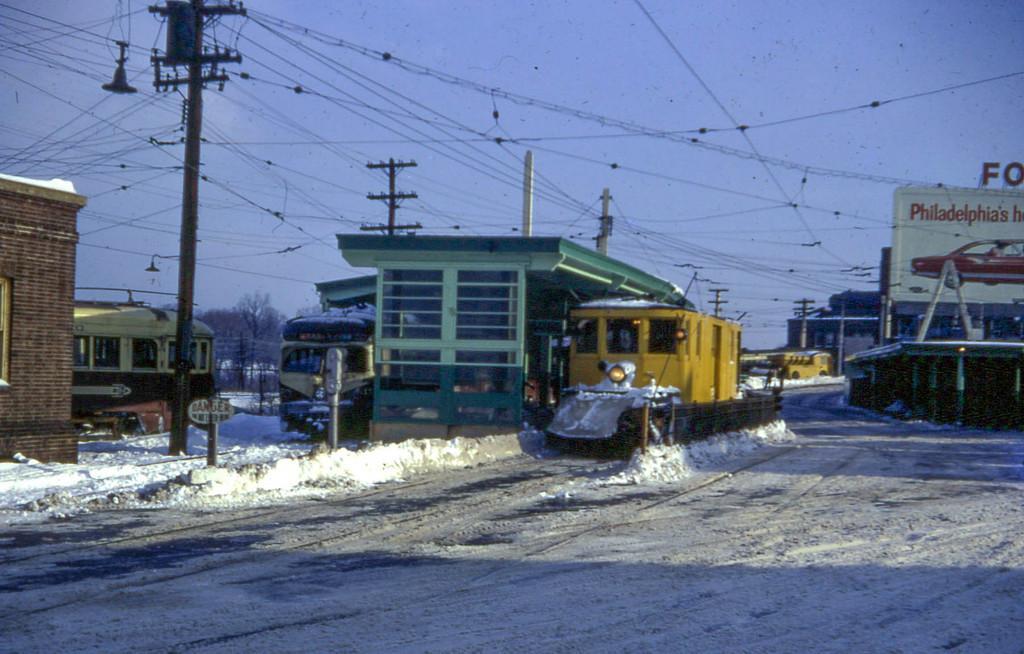Can you describe this image briefly? In this image I can see few trains. I can see few electrical poles and wires. On the right side there is a hoarding. There is some snow on the ground. At the top I can see the sky. 